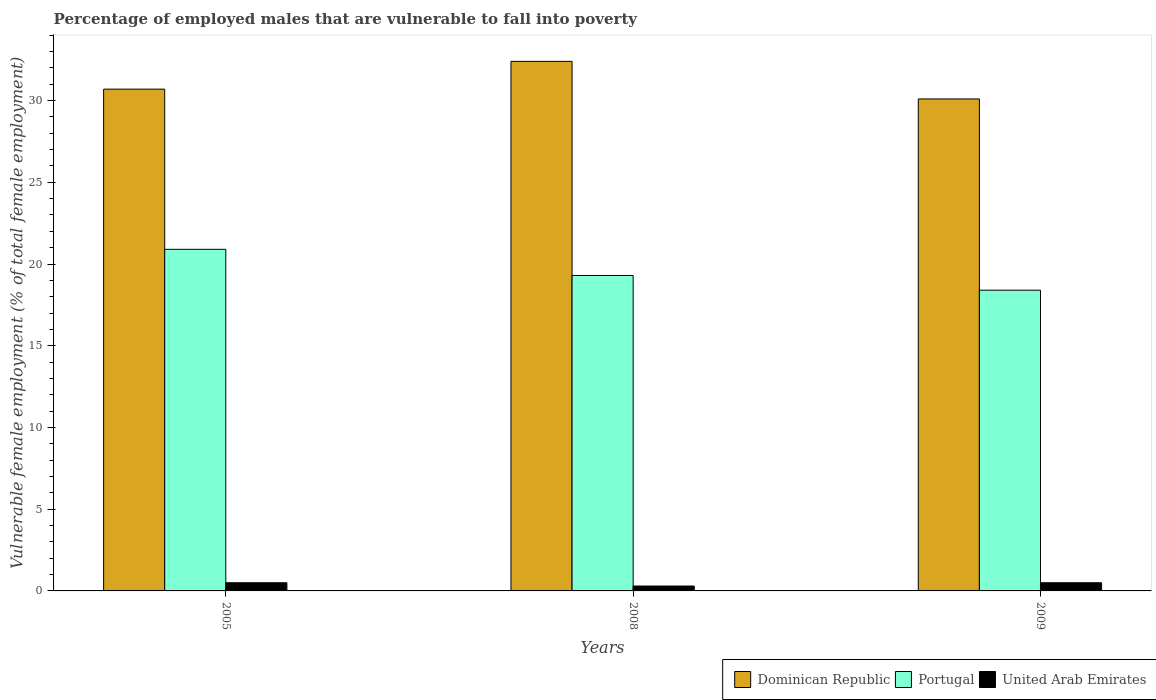Are the number of bars per tick equal to the number of legend labels?
Keep it short and to the point. Yes. Are the number of bars on each tick of the X-axis equal?
Provide a succinct answer. Yes. In how many cases, is the number of bars for a given year not equal to the number of legend labels?
Provide a succinct answer. 0. What is the percentage of employed males who are vulnerable to fall into poverty in Dominican Republic in 2009?
Your answer should be very brief. 30.1. Across all years, what is the maximum percentage of employed males who are vulnerable to fall into poverty in Dominican Republic?
Your response must be concise. 32.4. Across all years, what is the minimum percentage of employed males who are vulnerable to fall into poverty in United Arab Emirates?
Your answer should be very brief. 0.3. In which year was the percentage of employed males who are vulnerable to fall into poverty in Portugal minimum?
Provide a short and direct response. 2009. What is the total percentage of employed males who are vulnerable to fall into poverty in Portugal in the graph?
Ensure brevity in your answer.  58.6. What is the difference between the percentage of employed males who are vulnerable to fall into poverty in Portugal in 2008 and that in 2009?
Your response must be concise. 0.9. What is the difference between the percentage of employed males who are vulnerable to fall into poverty in United Arab Emirates in 2005 and the percentage of employed males who are vulnerable to fall into poverty in Dominican Republic in 2009?
Your response must be concise. -29.6. What is the average percentage of employed males who are vulnerable to fall into poverty in Dominican Republic per year?
Ensure brevity in your answer.  31.07. In the year 2009, what is the difference between the percentage of employed males who are vulnerable to fall into poverty in Dominican Republic and percentage of employed males who are vulnerable to fall into poverty in United Arab Emirates?
Your answer should be very brief. 29.6. What is the ratio of the percentage of employed males who are vulnerable to fall into poverty in Portugal in 2008 to that in 2009?
Provide a short and direct response. 1.05. Is the difference between the percentage of employed males who are vulnerable to fall into poverty in Dominican Republic in 2005 and 2009 greater than the difference between the percentage of employed males who are vulnerable to fall into poverty in United Arab Emirates in 2005 and 2009?
Your answer should be compact. Yes. What is the difference between the highest and the second highest percentage of employed males who are vulnerable to fall into poverty in Portugal?
Make the answer very short. 1.6. What is the difference between the highest and the lowest percentage of employed males who are vulnerable to fall into poverty in Dominican Republic?
Offer a terse response. 2.3. What does the 1st bar from the left in 2008 represents?
Offer a very short reply. Dominican Republic. How many bars are there?
Your answer should be very brief. 9. Does the graph contain grids?
Keep it short and to the point. No. Where does the legend appear in the graph?
Provide a short and direct response. Bottom right. What is the title of the graph?
Your response must be concise. Percentage of employed males that are vulnerable to fall into poverty. Does "East Asia (all income levels)" appear as one of the legend labels in the graph?
Make the answer very short. No. What is the label or title of the X-axis?
Ensure brevity in your answer.  Years. What is the label or title of the Y-axis?
Offer a terse response. Vulnerable female employment (% of total female employment). What is the Vulnerable female employment (% of total female employment) in Dominican Republic in 2005?
Give a very brief answer. 30.7. What is the Vulnerable female employment (% of total female employment) of Portugal in 2005?
Make the answer very short. 20.9. What is the Vulnerable female employment (% of total female employment) of Dominican Republic in 2008?
Keep it short and to the point. 32.4. What is the Vulnerable female employment (% of total female employment) in Portugal in 2008?
Provide a succinct answer. 19.3. What is the Vulnerable female employment (% of total female employment) of United Arab Emirates in 2008?
Your answer should be very brief. 0.3. What is the Vulnerable female employment (% of total female employment) of Dominican Republic in 2009?
Offer a very short reply. 30.1. What is the Vulnerable female employment (% of total female employment) in Portugal in 2009?
Offer a very short reply. 18.4. What is the Vulnerable female employment (% of total female employment) in United Arab Emirates in 2009?
Provide a short and direct response. 0.5. Across all years, what is the maximum Vulnerable female employment (% of total female employment) in Dominican Republic?
Your response must be concise. 32.4. Across all years, what is the maximum Vulnerable female employment (% of total female employment) in Portugal?
Offer a very short reply. 20.9. Across all years, what is the minimum Vulnerable female employment (% of total female employment) of Dominican Republic?
Your response must be concise. 30.1. Across all years, what is the minimum Vulnerable female employment (% of total female employment) of Portugal?
Give a very brief answer. 18.4. Across all years, what is the minimum Vulnerable female employment (% of total female employment) of United Arab Emirates?
Your answer should be very brief. 0.3. What is the total Vulnerable female employment (% of total female employment) of Dominican Republic in the graph?
Provide a succinct answer. 93.2. What is the total Vulnerable female employment (% of total female employment) in Portugal in the graph?
Make the answer very short. 58.6. What is the total Vulnerable female employment (% of total female employment) in United Arab Emirates in the graph?
Make the answer very short. 1.3. What is the difference between the Vulnerable female employment (% of total female employment) in Dominican Republic in 2005 and that in 2008?
Provide a short and direct response. -1.7. What is the difference between the Vulnerable female employment (% of total female employment) in United Arab Emirates in 2005 and that in 2008?
Ensure brevity in your answer.  0.2. What is the difference between the Vulnerable female employment (% of total female employment) of Dominican Republic in 2005 and that in 2009?
Offer a very short reply. 0.6. What is the difference between the Vulnerable female employment (% of total female employment) of Portugal in 2005 and that in 2009?
Keep it short and to the point. 2.5. What is the difference between the Vulnerable female employment (% of total female employment) in Dominican Republic in 2008 and that in 2009?
Your answer should be very brief. 2.3. What is the difference between the Vulnerable female employment (% of total female employment) of Portugal in 2008 and that in 2009?
Offer a terse response. 0.9. What is the difference between the Vulnerable female employment (% of total female employment) in United Arab Emirates in 2008 and that in 2009?
Provide a short and direct response. -0.2. What is the difference between the Vulnerable female employment (% of total female employment) in Dominican Republic in 2005 and the Vulnerable female employment (% of total female employment) in United Arab Emirates in 2008?
Provide a short and direct response. 30.4. What is the difference between the Vulnerable female employment (% of total female employment) in Portugal in 2005 and the Vulnerable female employment (% of total female employment) in United Arab Emirates in 2008?
Offer a very short reply. 20.6. What is the difference between the Vulnerable female employment (% of total female employment) in Dominican Republic in 2005 and the Vulnerable female employment (% of total female employment) in Portugal in 2009?
Give a very brief answer. 12.3. What is the difference between the Vulnerable female employment (% of total female employment) of Dominican Republic in 2005 and the Vulnerable female employment (% of total female employment) of United Arab Emirates in 2009?
Offer a very short reply. 30.2. What is the difference between the Vulnerable female employment (% of total female employment) in Portugal in 2005 and the Vulnerable female employment (% of total female employment) in United Arab Emirates in 2009?
Ensure brevity in your answer.  20.4. What is the difference between the Vulnerable female employment (% of total female employment) of Dominican Republic in 2008 and the Vulnerable female employment (% of total female employment) of United Arab Emirates in 2009?
Your answer should be compact. 31.9. What is the average Vulnerable female employment (% of total female employment) in Dominican Republic per year?
Your response must be concise. 31.07. What is the average Vulnerable female employment (% of total female employment) in Portugal per year?
Your response must be concise. 19.53. What is the average Vulnerable female employment (% of total female employment) in United Arab Emirates per year?
Your response must be concise. 0.43. In the year 2005, what is the difference between the Vulnerable female employment (% of total female employment) in Dominican Republic and Vulnerable female employment (% of total female employment) in Portugal?
Give a very brief answer. 9.8. In the year 2005, what is the difference between the Vulnerable female employment (% of total female employment) in Dominican Republic and Vulnerable female employment (% of total female employment) in United Arab Emirates?
Your answer should be compact. 30.2. In the year 2005, what is the difference between the Vulnerable female employment (% of total female employment) in Portugal and Vulnerable female employment (% of total female employment) in United Arab Emirates?
Provide a short and direct response. 20.4. In the year 2008, what is the difference between the Vulnerable female employment (% of total female employment) in Dominican Republic and Vulnerable female employment (% of total female employment) in Portugal?
Offer a terse response. 13.1. In the year 2008, what is the difference between the Vulnerable female employment (% of total female employment) in Dominican Republic and Vulnerable female employment (% of total female employment) in United Arab Emirates?
Offer a very short reply. 32.1. In the year 2008, what is the difference between the Vulnerable female employment (% of total female employment) in Portugal and Vulnerable female employment (% of total female employment) in United Arab Emirates?
Give a very brief answer. 19. In the year 2009, what is the difference between the Vulnerable female employment (% of total female employment) of Dominican Republic and Vulnerable female employment (% of total female employment) of Portugal?
Your answer should be very brief. 11.7. In the year 2009, what is the difference between the Vulnerable female employment (% of total female employment) of Dominican Republic and Vulnerable female employment (% of total female employment) of United Arab Emirates?
Provide a short and direct response. 29.6. In the year 2009, what is the difference between the Vulnerable female employment (% of total female employment) in Portugal and Vulnerable female employment (% of total female employment) in United Arab Emirates?
Your answer should be very brief. 17.9. What is the ratio of the Vulnerable female employment (% of total female employment) of Dominican Republic in 2005 to that in 2008?
Provide a succinct answer. 0.95. What is the ratio of the Vulnerable female employment (% of total female employment) of Portugal in 2005 to that in 2008?
Provide a short and direct response. 1.08. What is the ratio of the Vulnerable female employment (% of total female employment) of Dominican Republic in 2005 to that in 2009?
Make the answer very short. 1.02. What is the ratio of the Vulnerable female employment (% of total female employment) in Portugal in 2005 to that in 2009?
Ensure brevity in your answer.  1.14. What is the ratio of the Vulnerable female employment (% of total female employment) of United Arab Emirates in 2005 to that in 2009?
Offer a very short reply. 1. What is the ratio of the Vulnerable female employment (% of total female employment) in Dominican Republic in 2008 to that in 2009?
Your response must be concise. 1.08. What is the ratio of the Vulnerable female employment (% of total female employment) of Portugal in 2008 to that in 2009?
Keep it short and to the point. 1.05. What is the ratio of the Vulnerable female employment (% of total female employment) of United Arab Emirates in 2008 to that in 2009?
Provide a short and direct response. 0.6. What is the difference between the highest and the second highest Vulnerable female employment (% of total female employment) of Dominican Republic?
Your answer should be very brief. 1.7. What is the difference between the highest and the second highest Vulnerable female employment (% of total female employment) in Portugal?
Ensure brevity in your answer.  1.6. 